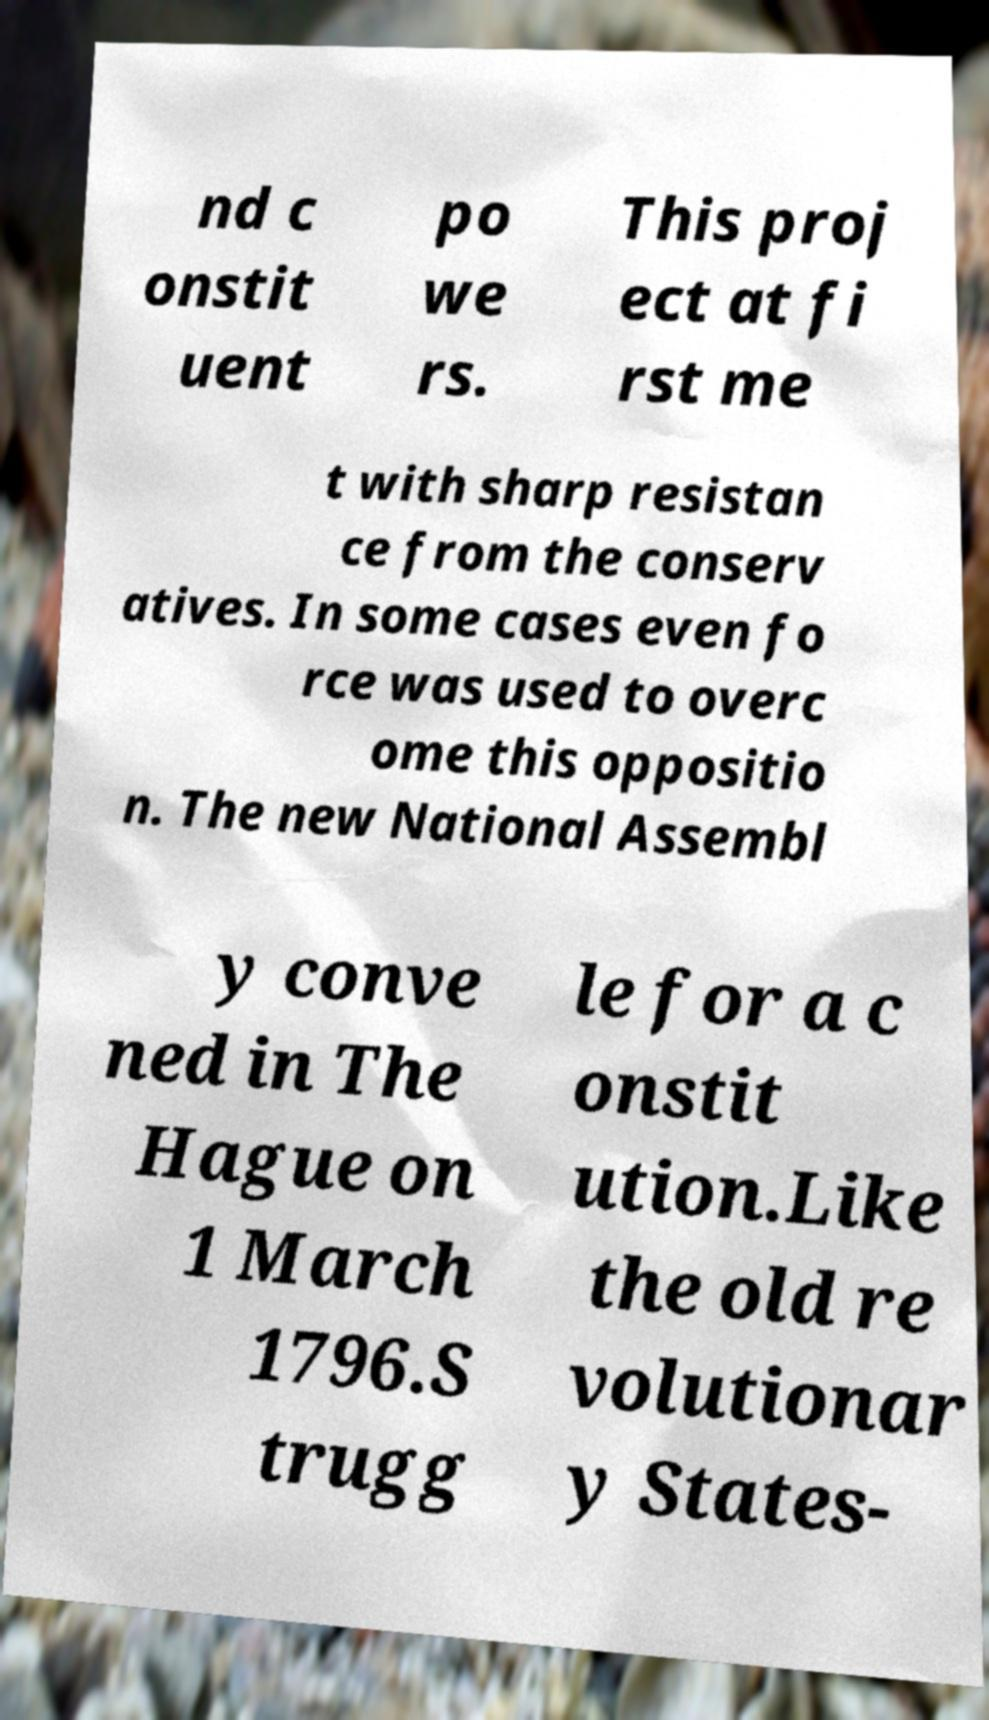What messages or text are displayed in this image? I need them in a readable, typed format. nd c onstit uent po we rs. This proj ect at fi rst me t with sharp resistan ce from the conserv atives. In some cases even fo rce was used to overc ome this oppositio n. The new National Assembl y conve ned in The Hague on 1 March 1796.S trugg le for a c onstit ution.Like the old re volutionar y States- 